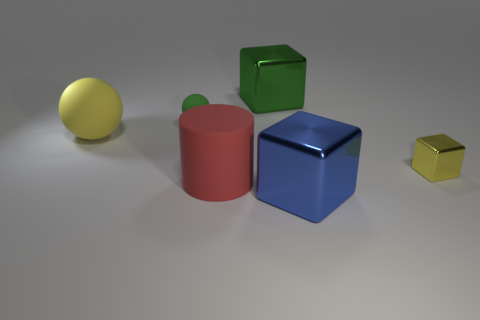There is a green thing that is the same size as the blue cube; what is it made of?
Your response must be concise. Metal. Does the rubber thing that is behind the big sphere have the same size as the yellow object that is left of the large green block?
Your response must be concise. No. How many things are yellow objects or things that are to the left of the big cylinder?
Offer a very short reply. 3. Is there a big green thing that has the same shape as the yellow metallic thing?
Offer a very short reply. Yes. There is a yellow thing on the right side of the large cube behind the large blue thing; what size is it?
Offer a very short reply. Small. Do the small block and the tiny ball have the same color?
Offer a terse response. No. What number of rubber objects are either large yellow spheres or brown balls?
Provide a short and direct response. 1. What number of small gray metal objects are there?
Your answer should be very brief. 0. Is the material of the green cube that is behind the large cylinder the same as the small thing that is on the right side of the blue metallic cube?
Give a very brief answer. Yes. What color is the other big metal object that is the same shape as the big green shiny thing?
Keep it short and to the point. Blue. 